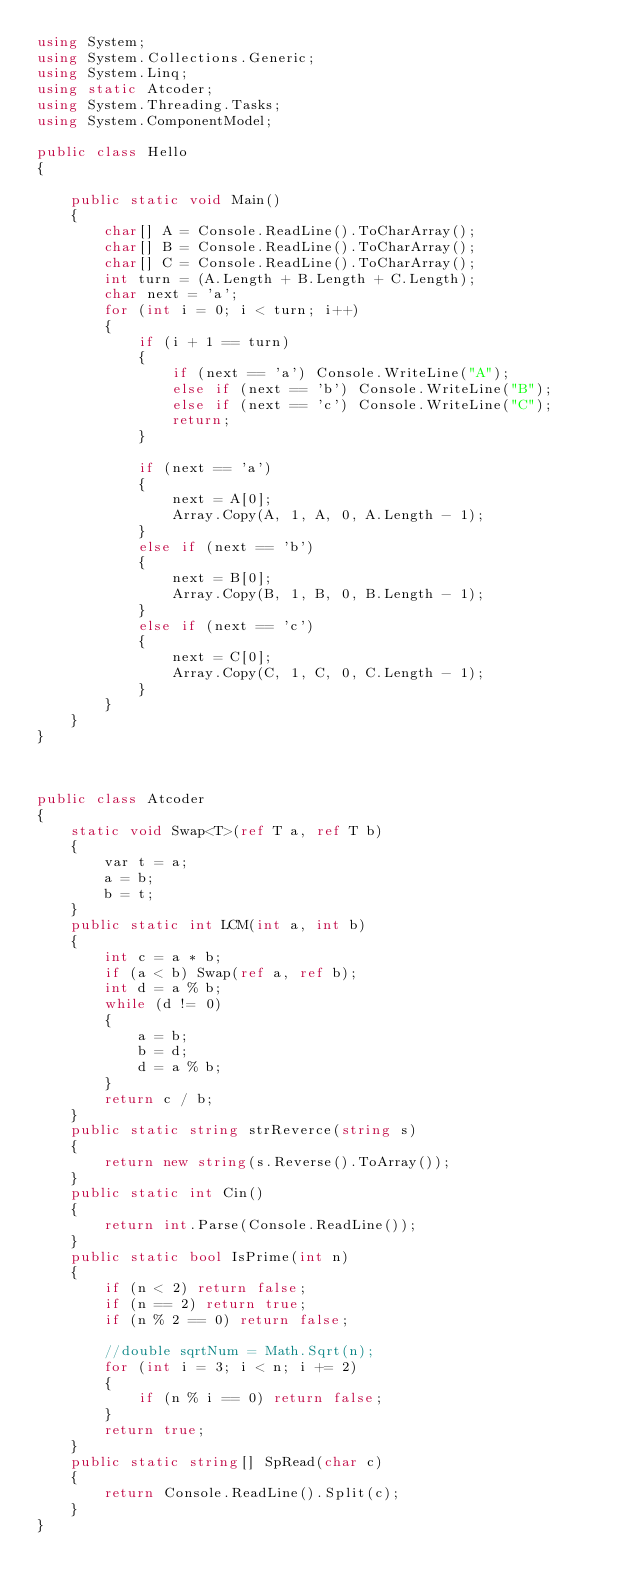Convert code to text. <code><loc_0><loc_0><loc_500><loc_500><_C#_>using System;
using System.Collections.Generic;
using System.Linq;
using static Atcoder;
using System.Threading.Tasks;
using System.ComponentModel;

public class Hello
{

    public static void Main()
    {
        char[] A = Console.ReadLine().ToCharArray();
        char[] B = Console.ReadLine().ToCharArray();
        char[] C = Console.ReadLine().ToCharArray();
        int turn = (A.Length + B.Length + C.Length);
        char next = 'a';
        for (int i = 0; i < turn; i++)
        {
            if (i + 1 == turn)
            {
                if (next == 'a') Console.WriteLine("A");
                else if (next == 'b') Console.WriteLine("B");
                else if (next == 'c') Console.WriteLine("C");
                return;
            }

            if (next == 'a')
            {
                next = A[0];
                Array.Copy(A, 1, A, 0, A.Length - 1);
            }
            else if (next == 'b')
            {
                next = B[0];
                Array.Copy(B, 1, B, 0, B.Length - 1);
            }
            else if (next == 'c')
            {
                next = C[0];
                Array.Copy(C, 1, C, 0, C.Length - 1);
            }
        }
    }
}



public class Atcoder
{
    static void Swap<T>(ref T a, ref T b)
    {
        var t = a;
        a = b;
        b = t;
    }
    public static int LCM(int a, int b)
    {
        int c = a * b;
        if (a < b) Swap(ref a, ref b);
        int d = a % b;
        while (d != 0)
        {
            a = b;
            b = d;
            d = a % b;
        }
        return c / b;
    }
    public static string strReverce(string s)
    {
        return new string(s.Reverse().ToArray());
    }
    public static int Cin()
    {
        return int.Parse(Console.ReadLine());
    }
    public static bool IsPrime(int n)
    {
        if (n < 2) return false;
        if (n == 2) return true;
        if (n % 2 == 0) return false;

        //double sqrtNum = Math.Sqrt(n);
        for (int i = 3; i < n; i += 2)
        {
            if (n % i == 0) return false;
        }
        return true;
    }
    public static string[] SpRead(char c)
    {
        return Console.ReadLine().Split(c);
    }
}
</code> 